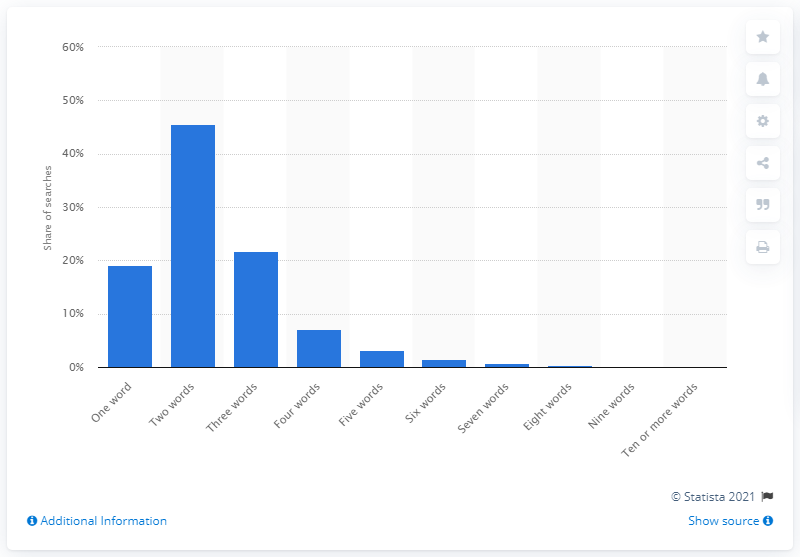Mention a couple of crucial points in this snapshot. According to the given statistic, a significant percentage of Canadian online searches consisted of single-word queries, specifically 19.1%. 